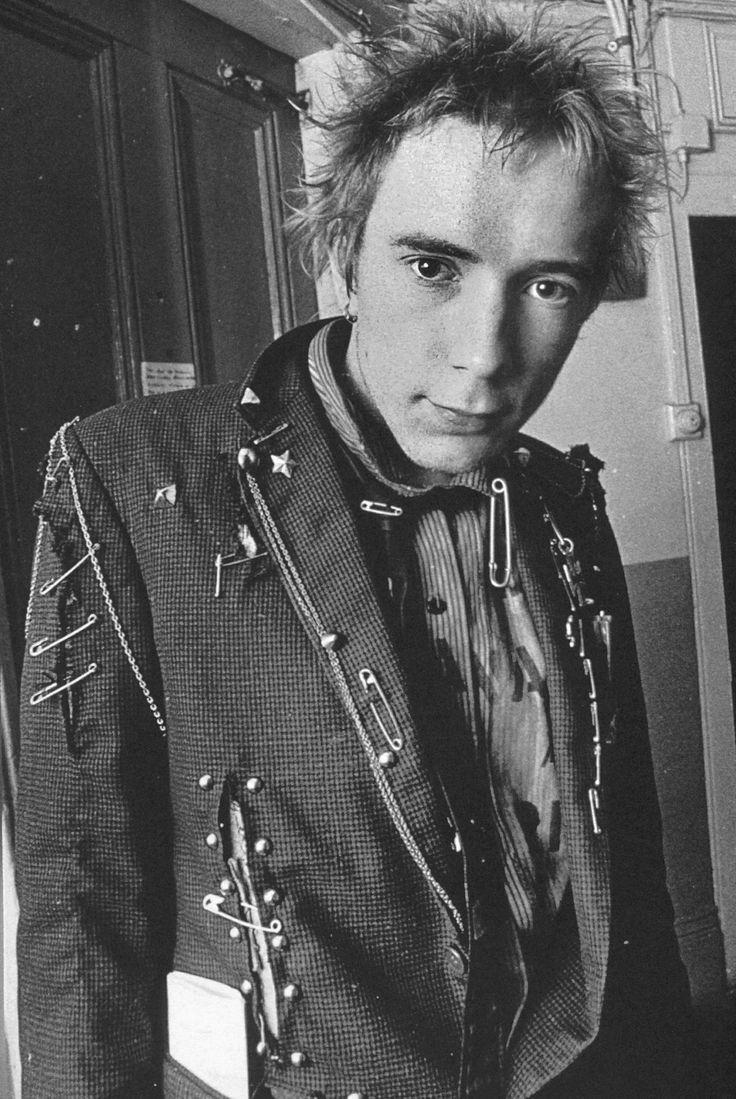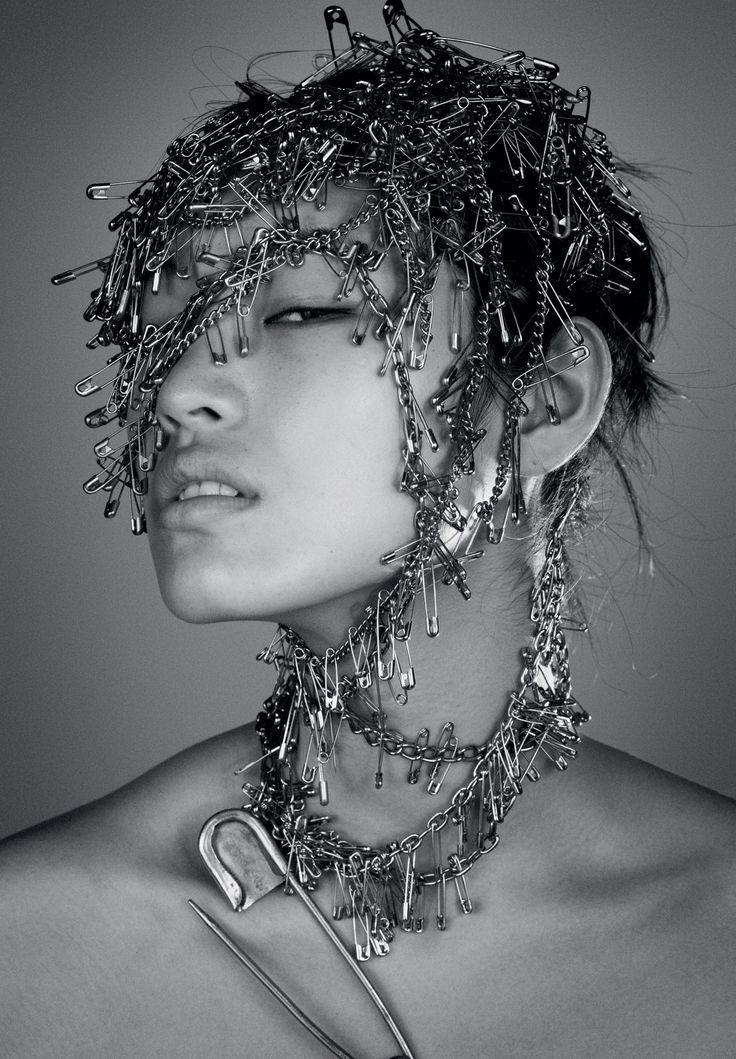The first image is the image on the left, the second image is the image on the right. Given the left and right images, does the statement "The left image includes some depiction of safety pins, and the right image features at least one spike-studded leather jacket." hold true? Answer yes or no. No. The first image is the image on the left, the second image is the image on the right. Evaluate the accuracy of this statement regarding the images: "One of the images features a jacket held together with several safety pins.". Is it true? Answer yes or no. Yes. 